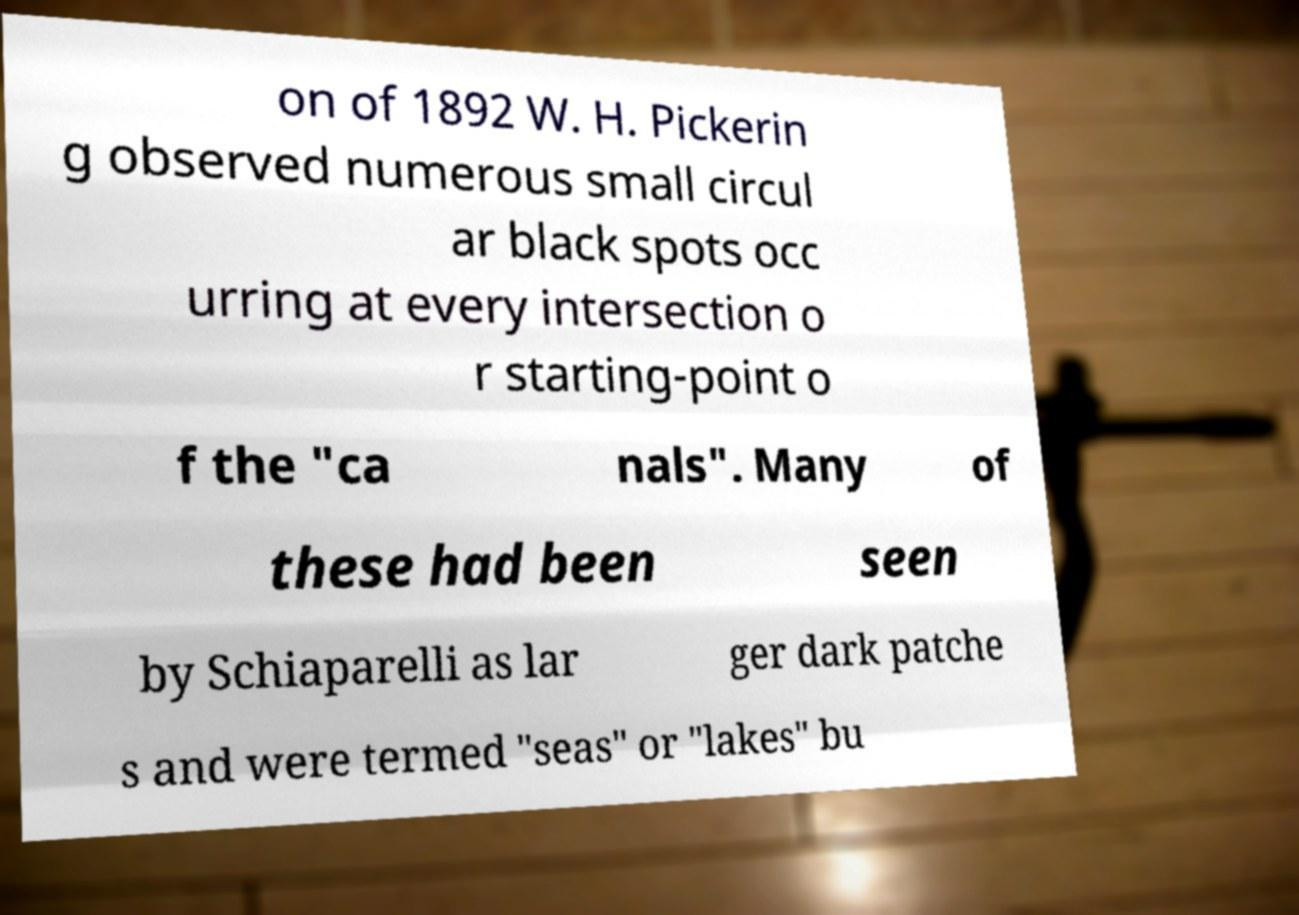Please identify and transcribe the text found in this image. on of 1892 W. H. Pickerin g observed numerous small circul ar black spots occ urring at every intersection o r starting-point o f the "ca nals". Many of these had been seen by Schiaparelli as lar ger dark patche s and were termed "seas" or "lakes" bu 